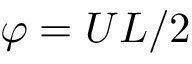Convert formula to latex. <formula><loc_0><loc_0><loc_500><loc_500>\varphi = U L / 2</formula> 